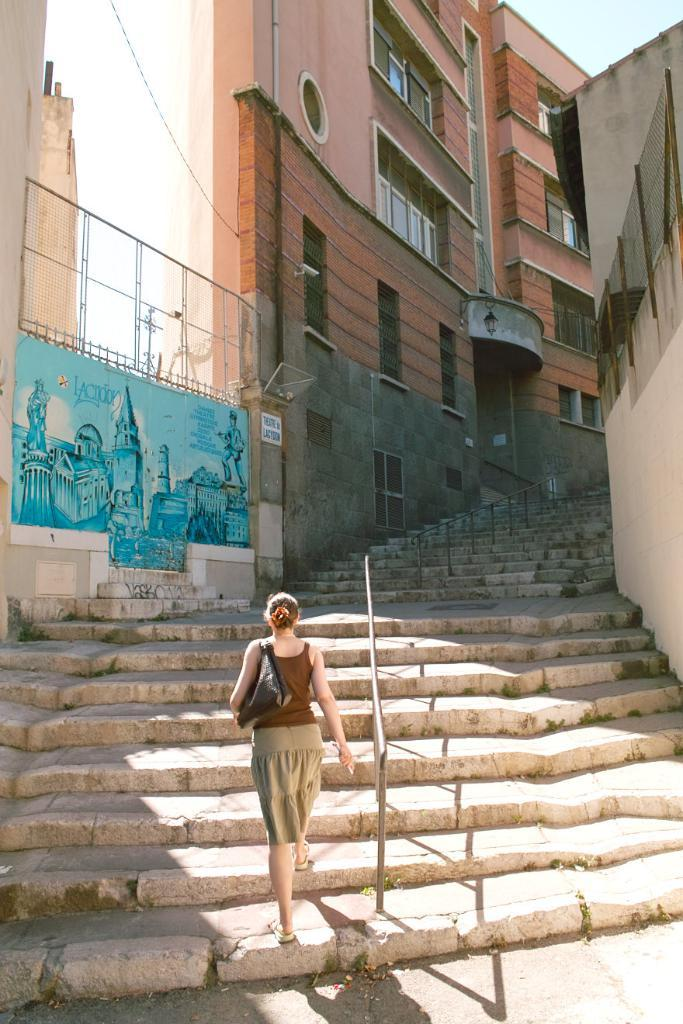What type of structures are present in the image? There are buildings with windows in the image. What feature do the buildings have? The buildings have stairs. What object can be seen in the image besides the buildings? There is a stand in the image. What is the lady in the image doing? A lady is walking in the image. What type of net can be seen hanging from the buildings in the image? There is no net present in the image; it features buildings with windows and a lady walking. What taste is associated with the buildings in the image? Buildings do not have a taste, as they are inanimate structures. 